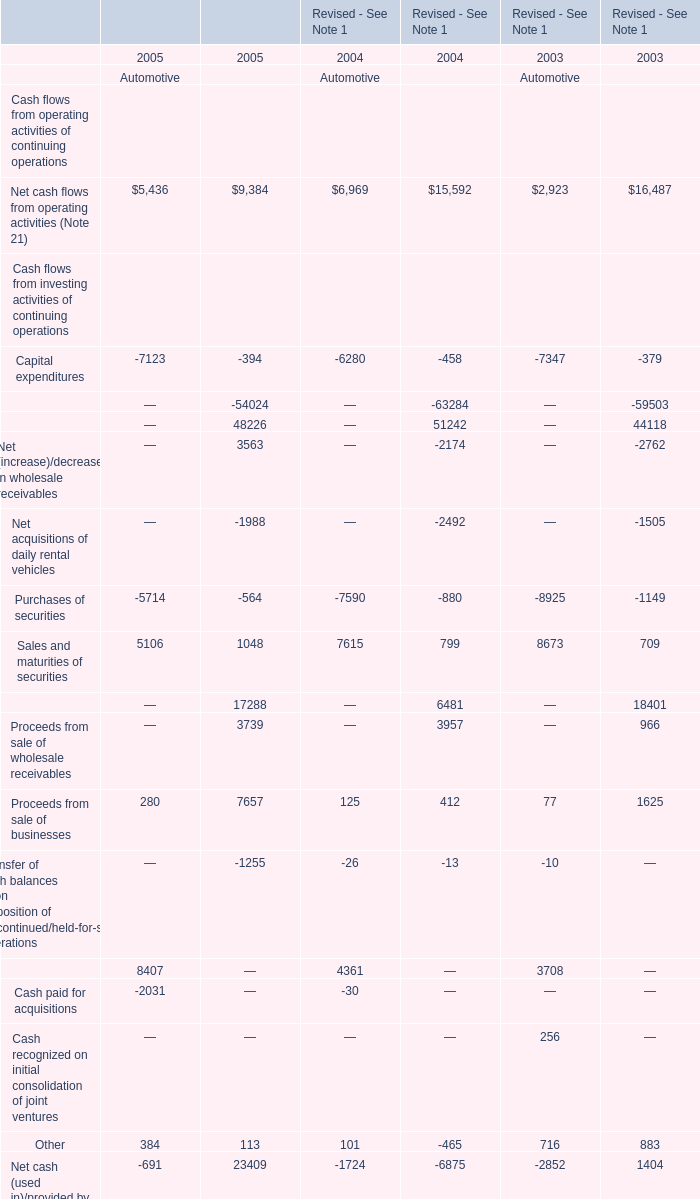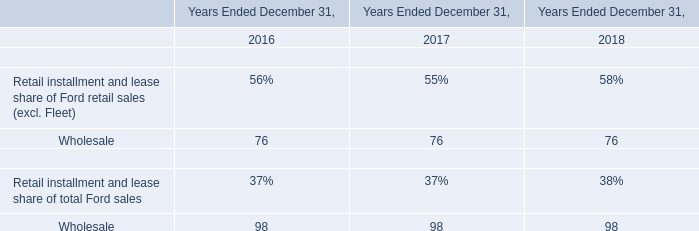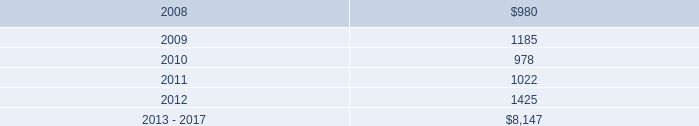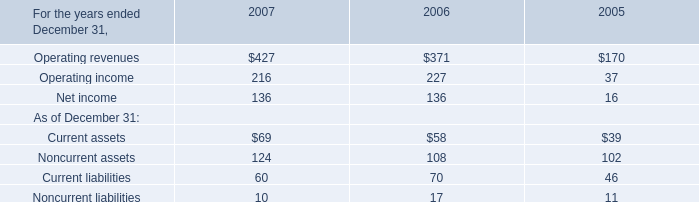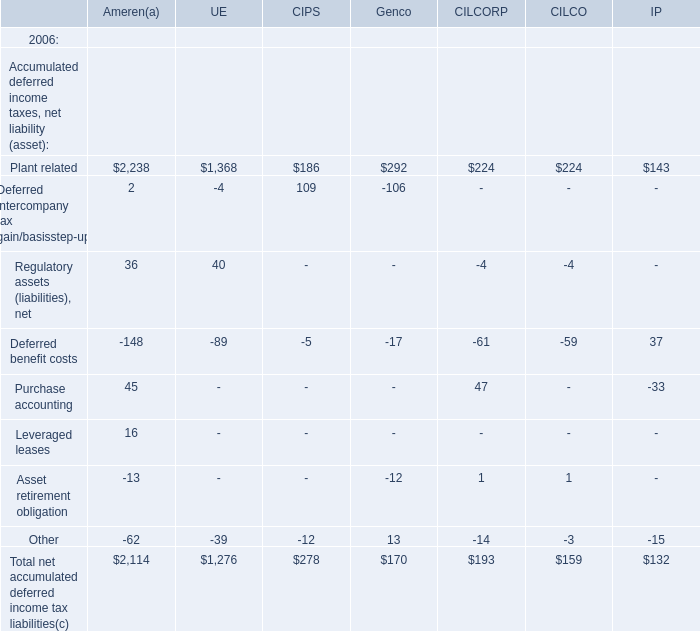What do all Automotive sum up without those Automotive smaller than 6000 in 2004? 
Computations: (((6969 + 7615) + 6856) + 10142)
Answer: 31582.0. 